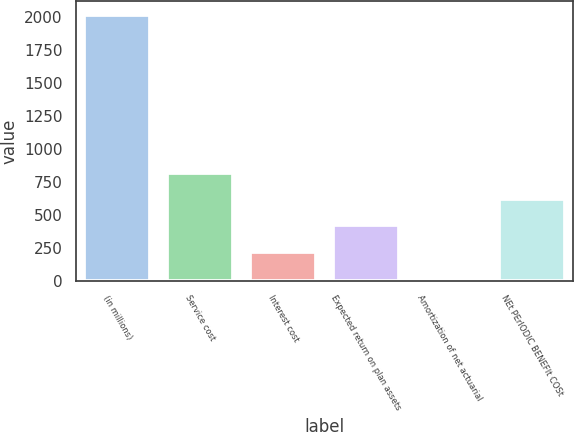Convert chart. <chart><loc_0><loc_0><loc_500><loc_500><bar_chart><fcel>(in millions)<fcel>Service cost<fcel>Interest cost<fcel>Expected return on plan assets<fcel>Amortization of net actuarial<fcel>NEt PErIODIC BENEFIt COSt<nl><fcel>2016<fcel>818.4<fcel>219.6<fcel>419.2<fcel>20<fcel>618.8<nl></chart> 